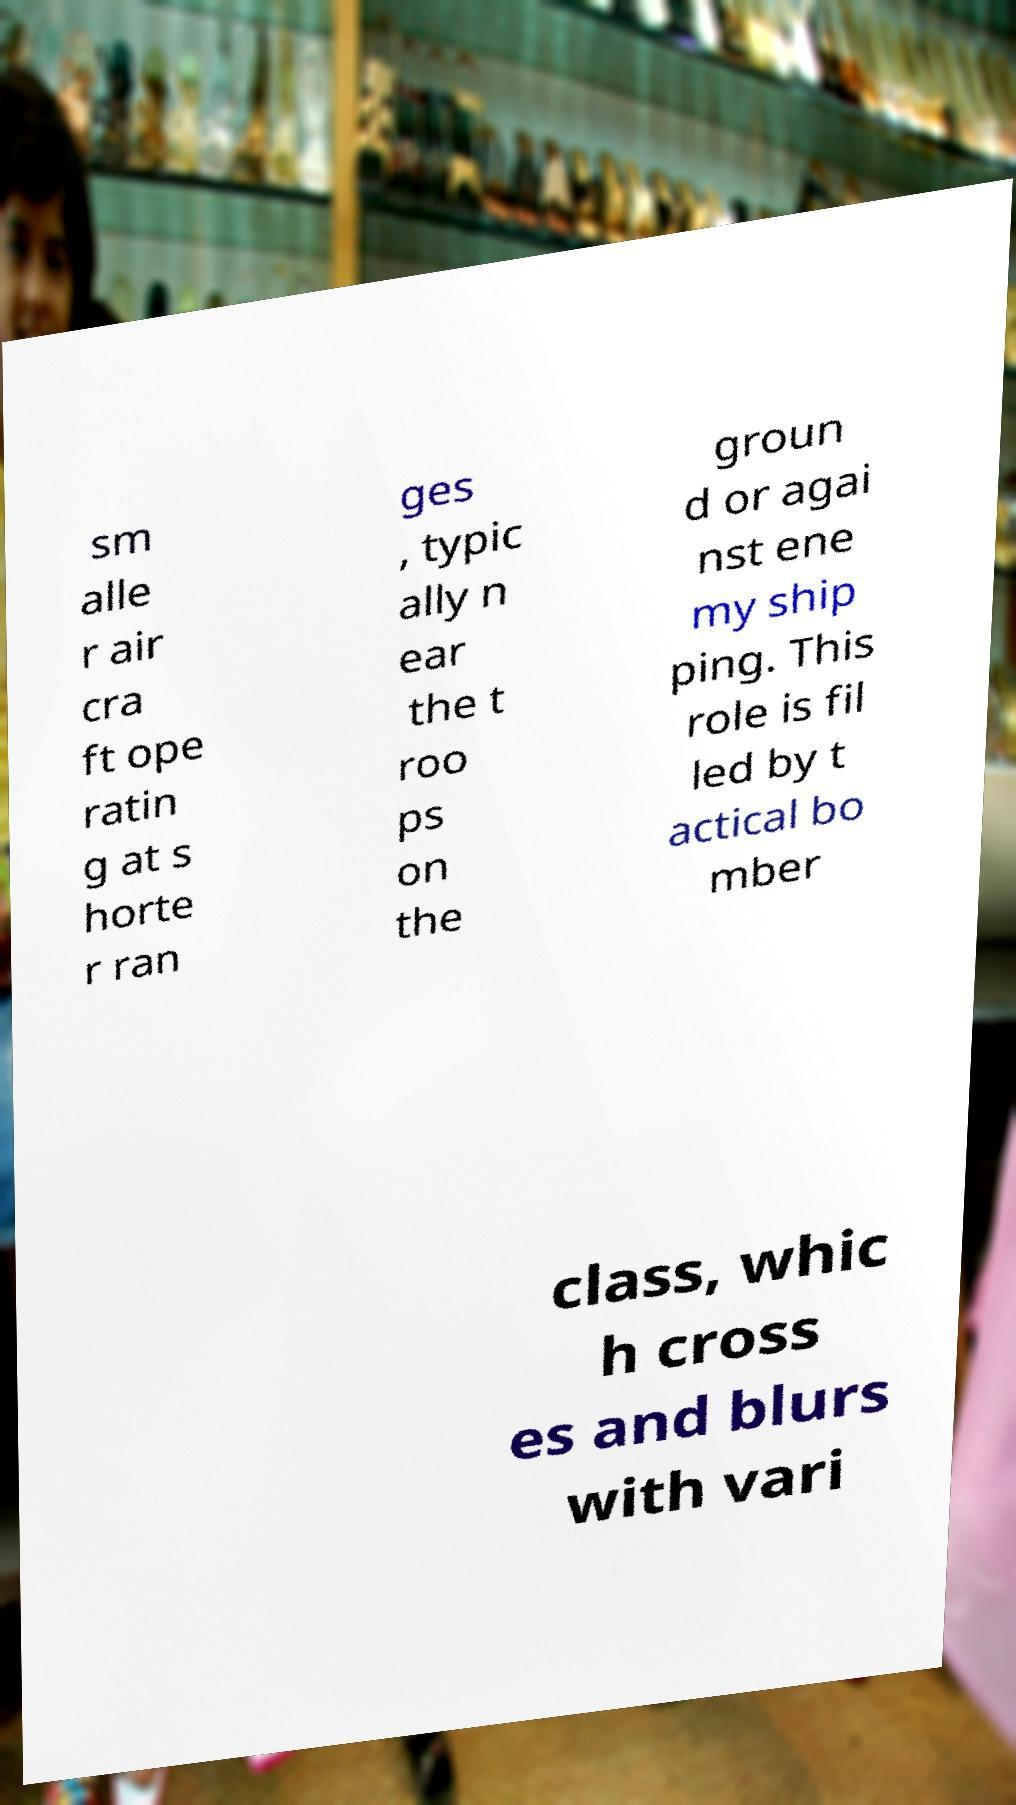Could you assist in decoding the text presented in this image and type it out clearly? sm alle r air cra ft ope ratin g at s horte r ran ges , typic ally n ear the t roo ps on the groun d or agai nst ene my ship ping. This role is fil led by t actical bo mber class, whic h cross es and blurs with vari 